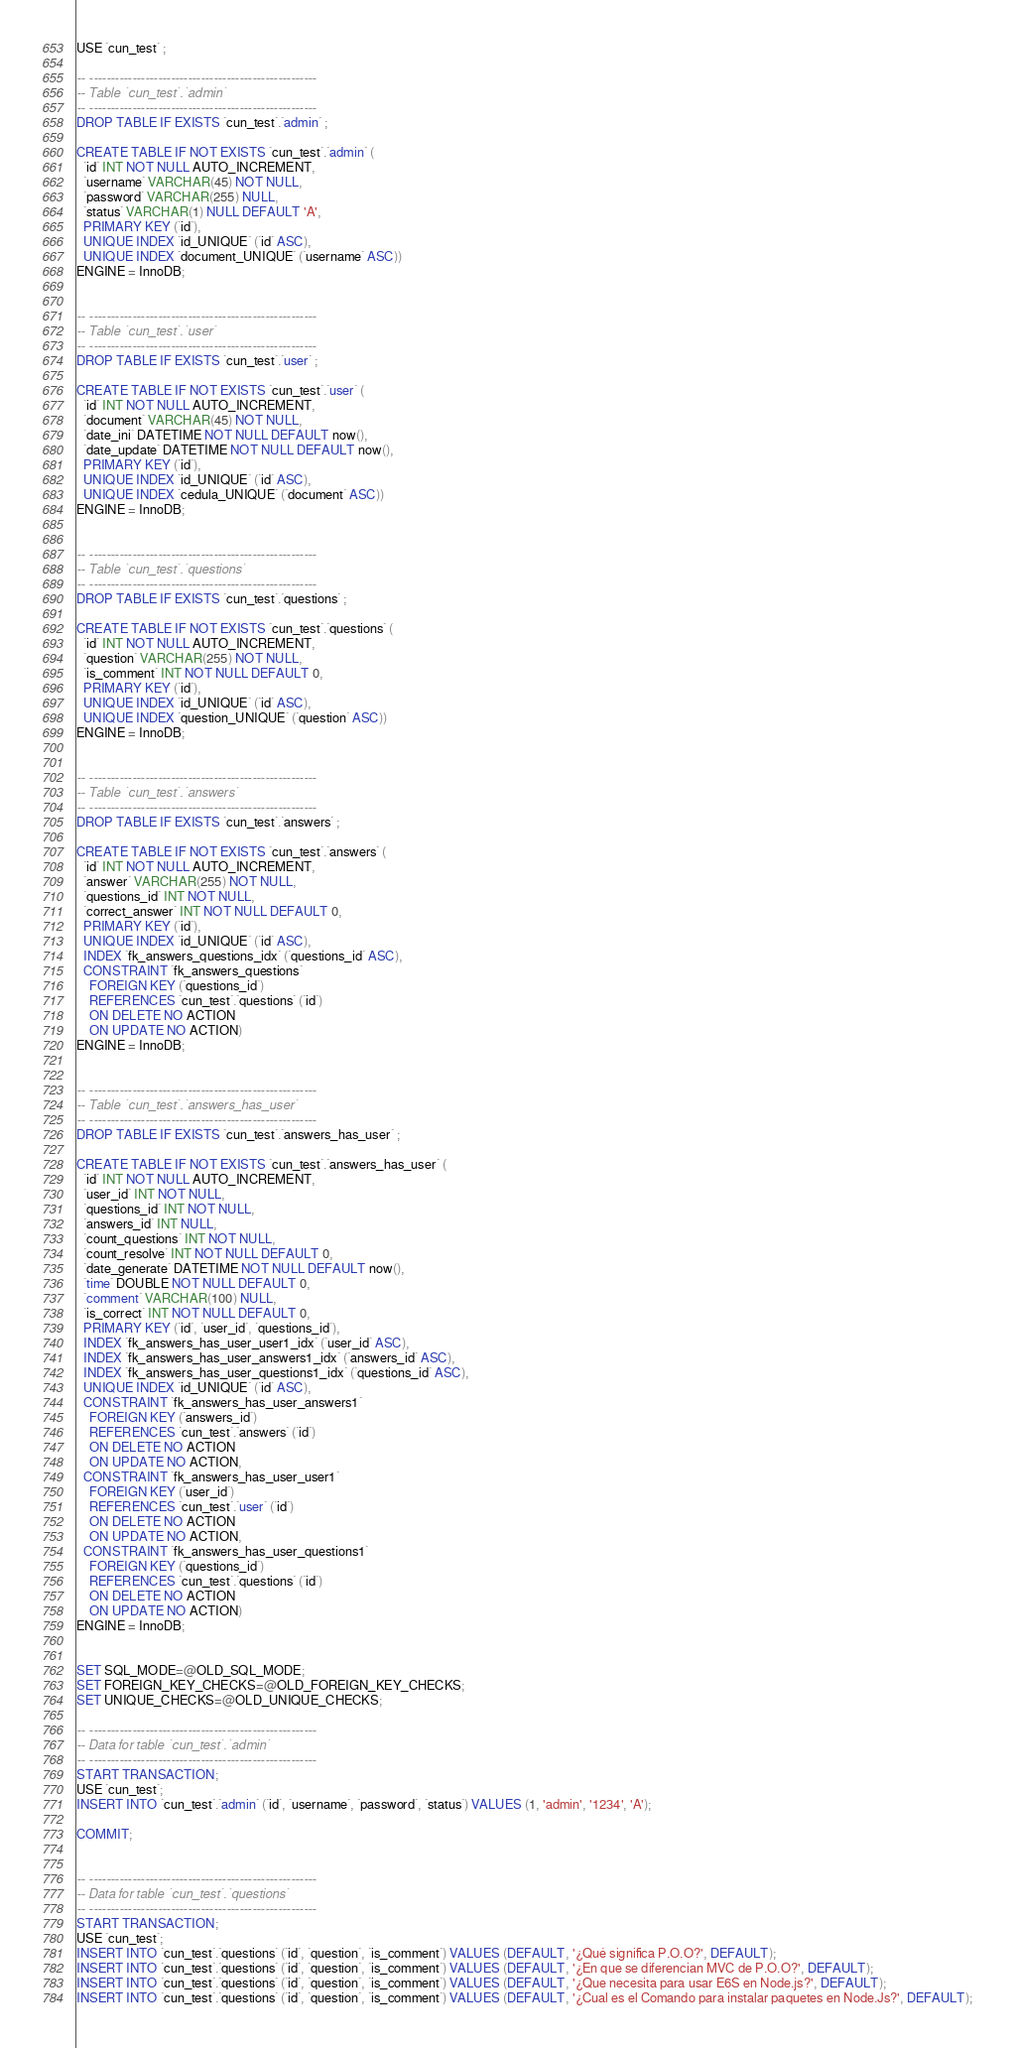<code> <loc_0><loc_0><loc_500><loc_500><_SQL_>USE `cun_test` ;

-- -----------------------------------------------------
-- Table `cun_test`.`admin`
-- -----------------------------------------------------
DROP TABLE IF EXISTS `cun_test`.`admin` ;

CREATE TABLE IF NOT EXISTS `cun_test`.`admin` (
  `id` INT NOT NULL AUTO_INCREMENT,
  `username` VARCHAR(45) NOT NULL,
  `password` VARCHAR(255) NULL,
  `status` VARCHAR(1) NULL DEFAULT 'A',
  PRIMARY KEY (`id`),
  UNIQUE INDEX `id_UNIQUE` (`id` ASC),
  UNIQUE INDEX `document_UNIQUE` (`username` ASC))
ENGINE = InnoDB;


-- -----------------------------------------------------
-- Table `cun_test`.`user`
-- -----------------------------------------------------
DROP TABLE IF EXISTS `cun_test`.`user` ;

CREATE TABLE IF NOT EXISTS `cun_test`.`user` (
  `id` INT NOT NULL AUTO_INCREMENT,
  `document` VARCHAR(45) NOT NULL,
  `date_ini` DATETIME NOT NULL DEFAULT now(),
  `date_update` DATETIME NOT NULL DEFAULT now(),
  PRIMARY KEY (`id`),
  UNIQUE INDEX `id_UNIQUE` (`id` ASC),
  UNIQUE INDEX `cedula_UNIQUE` (`document` ASC))
ENGINE = InnoDB;


-- -----------------------------------------------------
-- Table `cun_test`.`questions`
-- -----------------------------------------------------
DROP TABLE IF EXISTS `cun_test`.`questions` ;

CREATE TABLE IF NOT EXISTS `cun_test`.`questions` (
  `id` INT NOT NULL AUTO_INCREMENT,
  `question` VARCHAR(255) NOT NULL,
  `is_comment` INT NOT NULL DEFAULT 0,
  PRIMARY KEY (`id`),
  UNIQUE INDEX `id_UNIQUE` (`id` ASC),
  UNIQUE INDEX `question_UNIQUE` (`question` ASC))
ENGINE = InnoDB;


-- -----------------------------------------------------
-- Table `cun_test`.`answers`
-- -----------------------------------------------------
DROP TABLE IF EXISTS `cun_test`.`answers` ;

CREATE TABLE IF NOT EXISTS `cun_test`.`answers` (
  `id` INT NOT NULL AUTO_INCREMENT,
  `answer` VARCHAR(255) NOT NULL,
  `questions_id` INT NOT NULL,
  `correct_answer` INT NOT NULL DEFAULT 0,
  PRIMARY KEY (`id`),
  UNIQUE INDEX `id_UNIQUE` (`id` ASC),
  INDEX `fk_answers_questions_idx` (`questions_id` ASC),
  CONSTRAINT `fk_answers_questions`
    FOREIGN KEY (`questions_id`)
    REFERENCES `cun_test`.`questions` (`id`)
    ON DELETE NO ACTION
    ON UPDATE NO ACTION)
ENGINE = InnoDB;


-- -----------------------------------------------------
-- Table `cun_test`.`answers_has_user`
-- -----------------------------------------------------
DROP TABLE IF EXISTS `cun_test`.`answers_has_user` ;

CREATE TABLE IF NOT EXISTS `cun_test`.`answers_has_user` (
  `id` INT NOT NULL AUTO_INCREMENT,
  `user_id` INT NOT NULL,
  `questions_id` INT NOT NULL,
  `answers_id` INT NULL,
  `count_questions` INT NOT NULL,
  `count_resolve` INT NOT NULL DEFAULT 0,
  `date_generate` DATETIME NOT NULL DEFAULT now(),
  `time` DOUBLE NOT NULL DEFAULT 0,
  `comment` VARCHAR(100) NULL,
  `is_correct` INT NOT NULL DEFAULT 0,
  PRIMARY KEY (`id`, `user_id`, `questions_id`),
  INDEX `fk_answers_has_user_user1_idx` (`user_id` ASC),
  INDEX `fk_answers_has_user_answers1_idx` (`answers_id` ASC),
  INDEX `fk_answers_has_user_questions1_idx` (`questions_id` ASC),
  UNIQUE INDEX `id_UNIQUE` (`id` ASC),
  CONSTRAINT `fk_answers_has_user_answers1`
    FOREIGN KEY (`answers_id`)
    REFERENCES `cun_test`.`answers` (`id`)
    ON DELETE NO ACTION
    ON UPDATE NO ACTION,
  CONSTRAINT `fk_answers_has_user_user1`
    FOREIGN KEY (`user_id`)
    REFERENCES `cun_test`.`user` (`id`)
    ON DELETE NO ACTION
    ON UPDATE NO ACTION,
  CONSTRAINT `fk_answers_has_user_questions1`
    FOREIGN KEY (`questions_id`)
    REFERENCES `cun_test`.`questions` (`id`)
    ON DELETE NO ACTION
    ON UPDATE NO ACTION)
ENGINE = InnoDB;


SET SQL_MODE=@OLD_SQL_MODE;
SET FOREIGN_KEY_CHECKS=@OLD_FOREIGN_KEY_CHECKS;
SET UNIQUE_CHECKS=@OLD_UNIQUE_CHECKS;

-- -----------------------------------------------------
-- Data for table `cun_test`.`admin`
-- -----------------------------------------------------
START TRANSACTION;
USE `cun_test`;
INSERT INTO `cun_test`.`admin` (`id`, `username`, `password`, `status`) VALUES (1, 'admin', '1234', 'A');

COMMIT;


-- -----------------------------------------------------
-- Data for table `cun_test`.`questions`
-- -----------------------------------------------------
START TRANSACTION;
USE `cun_test`;
INSERT INTO `cun_test`.`questions` (`id`, `question`, `is_comment`) VALUES (DEFAULT, '¿Qué significa P.O.O?', DEFAULT);
INSERT INTO `cun_test`.`questions` (`id`, `question`, `is_comment`) VALUES (DEFAULT, '¿En que se diferencian MVC de P.O.O?', DEFAULT);
INSERT INTO `cun_test`.`questions` (`id`, `question`, `is_comment`) VALUES (DEFAULT, '¿Que necesita para usar E6S en Node.js?', DEFAULT);
INSERT INTO `cun_test`.`questions` (`id`, `question`, `is_comment`) VALUES (DEFAULT, '¿Cual es el Comando para instalar paquetes en Node.Js?', DEFAULT);</code> 